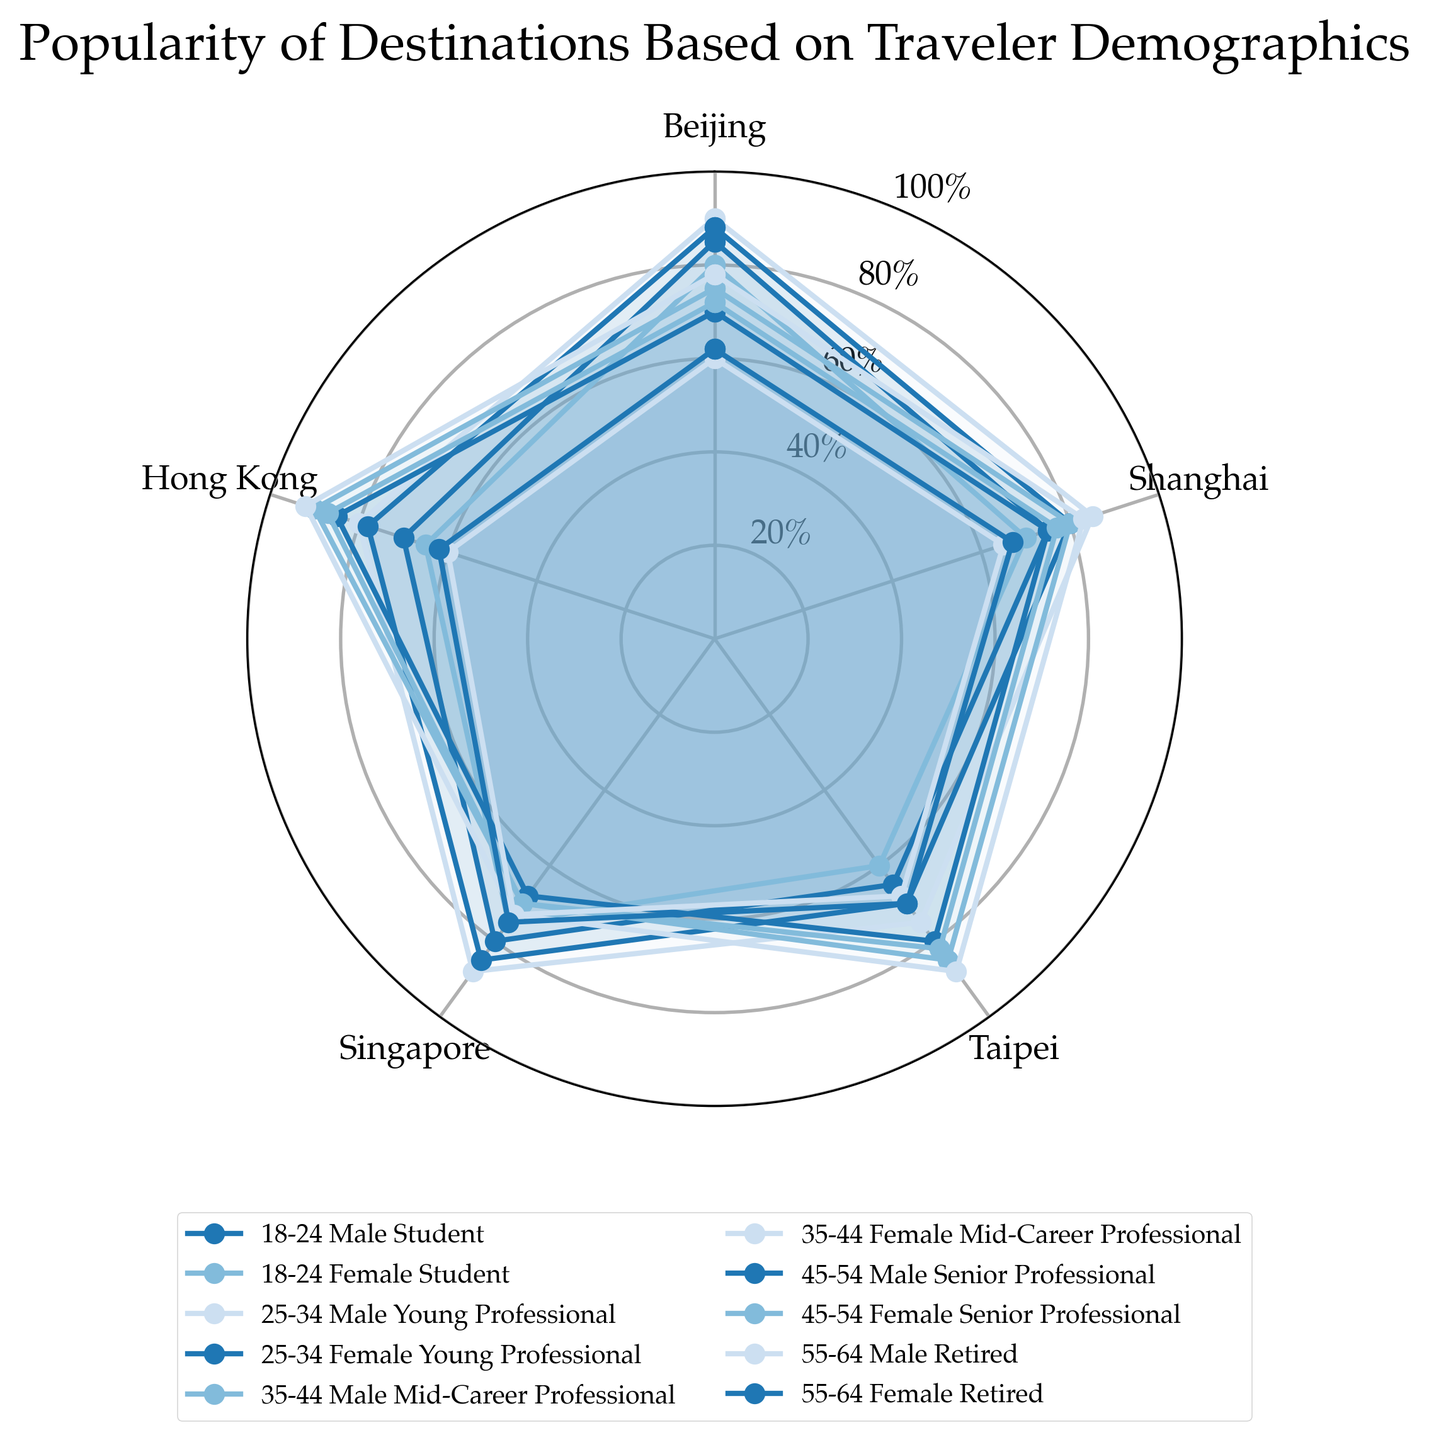What's the title of the chart? The title of the chart is located at the top and provides an overview of what the chart represents. It helps to understand the main context.
Answer: Popularity of Destinations Based on Traveler Demographics Which destination is most popular among 25-34 Female Young Professionals? By examining the radar chart, we focus on the line representing 25-34 Female Young Professionals and see which axis has the highest value.
Answer: Beijing What is the average popularity score for Taipei across all demographics? Sum the popularity scores of Taipei for each demographic group and divide by the total number of groups. (65+60+75+70+85+88+80+82+68+70) = 743. The average is 743 / 10
Answer: 74.3 How do the popularity scores for Beijing compare between 18-24 Male Students and 35-44 Female Mid-Career Professionals? Identify the values for Beijing for both groups from the chart (85 and 78). Compare them directly.
Answer: 85 for 18-24 Male Students, 78 for 35-44 Female Mid-Career Professionals Which age group shows a higher preference for Singapore, 45-54 or 55-64? Look at the scores for Singapore for both age groups across genders and compare. For 45-54, it's 68 and 70, and for 55-64, it's 73 and 75.
Answer: 55-64 Which demographic has the least interest in Hong Kong? By examining the radar chart, look for the lowest value along the Hong Kong axis across all lines. Find the corresponding demographic.
Answer: 55-64 Male Retired (60) If we sum the popularity scores of Singapore for all Female categories, what is the total? Identify and sum the Singapore scores for all female demographics. (75+85+73+70+75) = 378.
Answer: 378 How do the scores for Shanghai differ between 25-34 Male Young Professionals and 35-44 Male Mid-Career Professionals? Subtract the popularity scores for Shanghai for these two groups (85 - 80).
Answer: 5 Which occupation prefers Taipei the most? Identify the occupation linked to the highest score for Taipei. The highest score is 88 for 35-44 Female Mid-Career Professionals.
Answer: Mid-Career Professional Among 18-24 demographics, which gender has a higher score for Singapore? Compare the Singapore scores for Male and Female in the 18-24 age group (80 and 75).
Answer: Male 